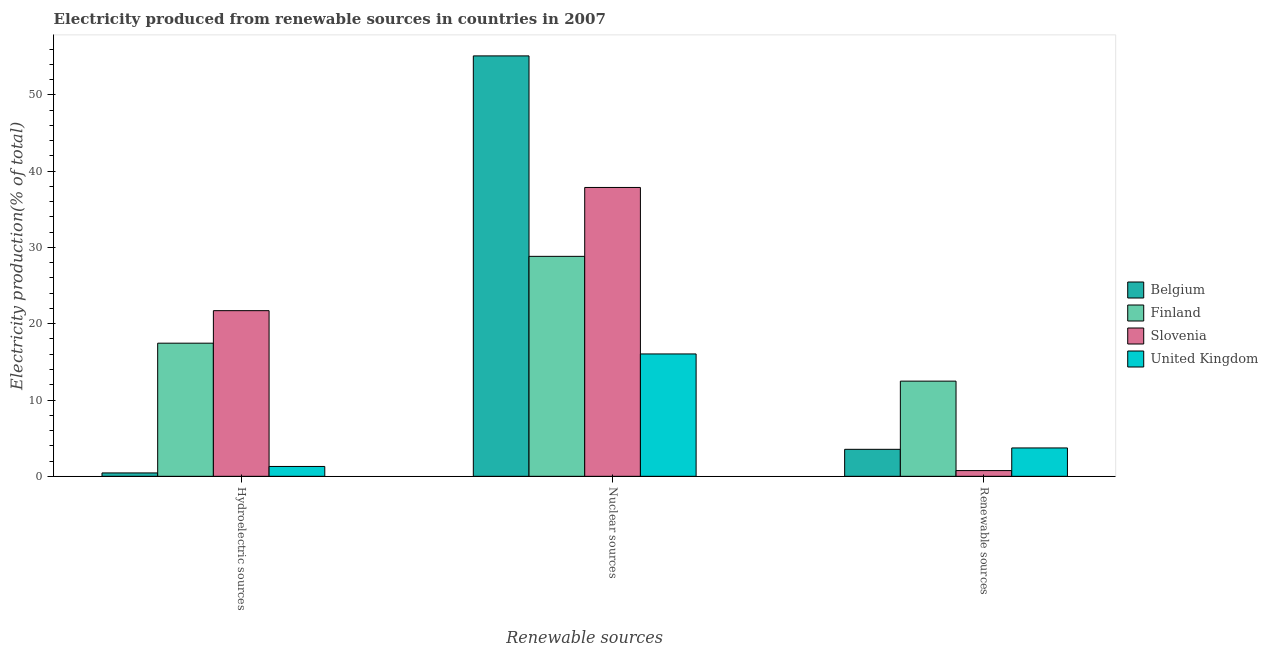How many different coloured bars are there?
Your answer should be compact. 4. How many groups of bars are there?
Your response must be concise. 3. Are the number of bars on each tick of the X-axis equal?
Your answer should be very brief. Yes. How many bars are there on the 2nd tick from the left?
Give a very brief answer. 4. What is the label of the 2nd group of bars from the left?
Your answer should be compact. Nuclear sources. What is the percentage of electricity produced by renewable sources in United Kingdom?
Your response must be concise. 3.72. Across all countries, what is the maximum percentage of electricity produced by nuclear sources?
Provide a succinct answer. 55.1. Across all countries, what is the minimum percentage of electricity produced by nuclear sources?
Offer a terse response. 16.04. In which country was the percentage of electricity produced by hydroelectric sources maximum?
Your answer should be compact. Slovenia. What is the total percentage of electricity produced by hydroelectric sources in the graph?
Offer a terse response. 40.9. What is the difference between the percentage of electricity produced by hydroelectric sources in United Kingdom and that in Finland?
Your answer should be very brief. -16.16. What is the difference between the percentage of electricity produced by renewable sources in Belgium and the percentage of electricity produced by hydroelectric sources in United Kingdom?
Provide a short and direct response. 2.25. What is the average percentage of electricity produced by hydroelectric sources per country?
Your answer should be very brief. 10.22. What is the difference between the percentage of electricity produced by nuclear sources and percentage of electricity produced by renewable sources in Belgium?
Your response must be concise. 51.56. What is the ratio of the percentage of electricity produced by renewable sources in United Kingdom to that in Slovenia?
Offer a terse response. 4.95. Is the percentage of electricity produced by hydroelectric sources in United Kingdom less than that in Slovenia?
Give a very brief answer. Yes. What is the difference between the highest and the second highest percentage of electricity produced by renewable sources?
Ensure brevity in your answer.  8.76. What is the difference between the highest and the lowest percentage of electricity produced by renewable sources?
Provide a short and direct response. 11.72. In how many countries, is the percentage of electricity produced by renewable sources greater than the average percentage of electricity produced by renewable sources taken over all countries?
Offer a very short reply. 1. What does the 2nd bar from the right in Nuclear sources represents?
Keep it short and to the point. Slovenia. Is it the case that in every country, the sum of the percentage of electricity produced by hydroelectric sources and percentage of electricity produced by nuclear sources is greater than the percentage of electricity produced by renewable sources?
Provide a short and direct response. Yes. How many bars are there?
Your answer should be very brief. 12. Are all the bars in the graph horizontal?
Provide a succinct answer. No. How many countries are there in the graph?
Your answer should be very brief. 4. Does the graph contain grids?
Keep it short and to the point. No. How are the legend labels stacked?
Keep it short and to the point. Vertical. What is the title of the graph?
Offer a terse response. Electricity produced from renewable sources in countries in 2007. What is the label or title of the X-axis?
Ensure brevity in your answer.  Renewable sources. What is the label or title of the Y-axis?
Your answer should be very brief. Electricity production(% of total). What is the Electricity production(% of total) of Belgium in Hydroelectric sources?
Your response must be concise. 0.44. What is the Electricity production(% of total) in Finland in Hydroelectric sources?
Your answer should be very brief. 17.45. What is the Electricity production(% of total) of Slovenia in Hydroelectric sources?
Provide a short and direct response. 21.71. What is the Electricity production(% of total) of United Kingdom in Hydroelectric sources?
Your response must be concise. 1.29. What is the Electricity production(% of total) of Belgium in Nuclear sources?
Your answer should be very brief. 55.1. What is the Electricity production(% of total) in Finland in Nuclear sources?
Your response must be concise. 28.83. What is the Electricity production(% of total) in Slovenia in Nuclear sources?
Keep it short and to the point. 37.86. What is the Electricity production(% of total) in United Kingdom in Nuclear sources?
Give a very brief answer. 16.04. What is the Electricity production(% of total) of Belgium in Renewable sources?
Provide a succinct answer. 3.54. What is the Electricity production(% of total) of Finland in Renewable sources?
Keep it short and to the point. 12.47. What is the Electricity production(% of total) of Slovenia in Renewable sources?
Provide a succinct answer. 0.75. What is the Electricity production(% of total) in United Kingdom in Renewable sources?
Your response must be concise. 3.72. Across all Renewable sources, what is the maximum Electricity production(% of total) of Belgium?
Provide a short and direct response. 55.1. Across all Renewable sources, what is the maximum Electricity production(% of total) of Finland?
Your answer should be very brief. 28.83. Across all Renewable sources, what is the maximum Electricity production(% of total) of Slovenia?
Ensure brevity in your answer.  37.86. Across all Renewable sources, what is the maximum Electricity production(% of total) in United Kingdom?
Provide a short and direct response. 16.04. Across all Renewable sources, what is the minimum Electricity production(% of total) in Belgium?
Offer a very short reply. 0.44. Across all Renewable sources, what is the minimum Electricity production(% of total) of Finland?
Ensure brevity in your answer.  12.47. Across all Renewable sources, what is the minimum Electricity production(% of total) of Slovenia?
Offer a terse response. 0.75. Across all Renewable sources, what is the minimum Electricity production(% of total) of United Kingdom?
Ensure brevity in your answer.  1.29. What is the total Electricity production(% of total) in Belgium in the graph?
Your answer should be very brief. 59.08. What is the total Electricity production(% of total) in Finland in the graph?
Provide a succinct answer. 58.75. What is the total Electricity production(% of total) in Slovenia in the graph?
Provide a succinct answer. 60.32. What is the total Electricity production(% of total) of United Kingdom in the graph?
Ensure brevity in your answer.  21.05. What is the difference between the Electricity production(% of total) of Belgium in Hydroelectric sources and that in Nuclear sources?
Your answer should be compact. -54.66. What is the difference between the Electricity production(% of total) in Finland in Hydroelectric sources and that in Nuclear sources?
Provide a short and direct response. -11.38. What is the difference between the Electricity production(% of total) in Slovenia in Hydroelectric sources and that in Nuclear sources?
Ensure brevity in your answer.  -16.15. What is the difference between the Electricity production(% of total) in United Kingdom in Hydroelectric sources and that in Nuclear sources?
Your answer should be compact. -14.75. What is the difference between the Electricity production(% of total) in Belgium in Hydroelectric sources and that in Renewable sources?
Your answer should be very brief. -3.09. What is the difference between the Electricity production(% of total) of Finland in Hydroelectric sources and that in Renewable sources?
Your answer should be compact. 4.97. What is the difference between the Electricity production(% of total) in Slovenia in Hydroelectric sources and that in Renewable sources?
Keep it short and to the point. 20.96. What is the difference between the Electricity production(% of total) of United Kingdom in Hydroelectric sources and that in Renewable sources?
Your answer should be very brief. -2.43. What is the difference between the Electricity production(% of total) of Belgium in Nuclear sources and that in Renewable sources?
Your answer should be compact. 51.56. What is the difference between the Electricity production(% of total) in Finland in Nuclear sources and that in Renewable sources?
Provide a succinct answer. 16.36. What is the difference between the Electricity production(% of total) in Slovenia in Nuclear sources and that in Renewable sources?
Your answer should be compact. 37.11. What is the difference between the Electricity production(% of total) in United Kingdom in Nuclear sources and that in Renewable sources?
Provide a short and direct response. 12.32. What is the difference between the Electricity production(% of total) of Belgium in Hydroelectric sources and the Electricity production(% of total) of Finland in Nuclear sources?
Your answer should be very brief. -28.38. What is the difference between the Electricity production(% of total) of Belgium in Hydroelectric sources and the Electricity production(% of total) of Slovenia in Nuclear sources?
Offer a terse response. -37.41. What is the difference between the Electricity production(% of total) in Belgium in Hydroelectric sources and the Electricity production(% of total) in United Kingdom in Nuclear sources?
Make the answer very short. -15.59. What is the difference between the Electricity production(% of total) of Finland in Hydroelectric sources and the Electricity production(% of total) of Slovenia in Nuclear sources?
Provide a short and direct response. -20.41. What is the difference between the Electricity production(% of total) in Finland in Hydroelectric sources and the Electricity production(% of total) in United Kingdom in Nuclear sources?
Offer a very short reply. 1.41. What is the difference between the Electricity production(% of total) in Slovenia in Hydroelectric sources and the Electricity production(% of total) in United Kingdom in Nuclear sources?
Offer a very short reply. 5.67. What is the difference between the Electricity production(% of total) of Belgium in Hydroelectric sources and the Electricity production(% of total) of Finland in Renewable sources?
Your answer should be compact. -12.03. What is the difference between the Electricity production(% of total) in Belgium in Hydroelectric sources and the Electricity production(% of total) in Slovenia in Renewable sources?
Offer a terse response. -0.31. What is the difference between the Electricity production(% of total) of Belgium in Hydroelectric sources and the Electricity production(% of total) of United Kingdom in Renewable sources?
Provide a succinct answer. -3.27. What is the difference between the Electricity production(% of total) of Finland in Hydroelectric sources and the Electricity production(% of total) of Slovenia in Renewable sources?
Your answer should be compact. 16.7. What is the difference between the Electricity production(% of total) of Finland in Hydroelectric sources and the Electricity production(% of total) of United Kingdom in Renewable sources?
Provide a succinct answer. 13.73. What is the difference between the Electricity production(% of total) of Slovenia in Hydroelectric sources and the Electricity production(% of total) of United Kingdom in Renewable sources?
Provide a short and direct response. 17.99. What is the difference between the Electricity production(% of total) of Belgium in Nuclear sources and the Electricity production(% of total) of Finland in Renewable sources?
Make the answer very short. 42.63. What is the difference between the Electricity production(% of total) in Belgium in Nuclear sources and the Electricity production(% of total) in Slovenia in Renewable sources?
Your answer should be very brief. 54.35. What is the difference between the Electricity production(% of total) in Belgium in Nuclear sources and the Electricity production(% of total) in United Kingdom in Renewable sources?
Provide a short and direct response. 51.38. What is the difference between the Electricity production(% of total) of Finland in Nuclear sources and the Electricity production(% of total) of Slovenia in Renewable sources?
Your answer should be compact. 28.08. What is the difference between the Electricity production(% of total) of Finland in Nuclear sources and the Electricity production(% of total) of United Kingdom in Renewable sources?
Give a very brief answer. 25.11. What is the difference between the Electricity production(% of total) of Slovenia in Nuclear sources and the Electricity production(% of total) of United Kingdom in Renewable sources?
Your response must be concise. 34.14. What is the average Electricity production(% of total) in Belgium per Renewable sources?
Keep it short and to the point. 19.69. What is the average Electricity production(% of total) in Finland per Renewable sources?
Keep it short and to the point. 19.58. What is the average Electricity production(% of total) in Slovenia per Renewable sources?
Your answer should be compact. 20.11. What is the average Electricity production(% of total) in United Kingdom per Renewable sources?
Ensure brevity in your answer.  7.02. What is the difference between the Electricity production(% of total) in Belgium and Electricity production(% of total) in Finland in Hydroelectric sources?
Provide a short and direct response. -17. What is the difference between the Electricity production(% of total) in Belgium and Electricity production(% of total) in Slovenia in Hydroelectric sources?
Make the answer very short. -21.27. What is the difference between the Electricity production(% of total) of Belgium and Electricity production(% of total) of United Kingdom in Hydroelectric sources?
Your answer should be compact. -0.85. What is the difference between the Electricity production(% of total) in Finland and Electricity production(% of total) in Slovenia in Hydroelectric sources?
Keep it short and to the point. -4.26. What is the difference between the Electricity production(% of total) of Finland and Electricity production(% of total) of United Kingdom in Hydroelectric sources?
Provide a succinct answer. 16.16. What is the difference between the Electricity production(% of total) of Slovenia and Electricity production(% of total) of United Kingdom in Hydroelectric sources?
Your answer should be compact. 20.42. What is the difference between the Electricity production(% of total) in Belgium and Electricity production(% of total) in Finland in Nuclear sources?
Keep it short and to the point. 26.27. What is the difference between the Electricity production(% of total) in Belgium and Electricity production(% of total) in Slovenia in Nuclear sources?
Keep it short and to the point. 17.24. What is the difference between the Electricity production(% of total) in Belgium and Electricity production(% of total) in United Kingdom in Nuclear sources?
Offer a very short reply. 39.06. What is the difference between the Electricity production(% of total) of Finland and Electricity production(% of total) of Slovenia in Nuclear sources?
Offer a very short reply. -9.03. What is the difference between the Electricity production(% of total) of Finland and Electricity production(% of total) of United Kingdom in Nuclear sources?
Ensure brevity in your answer.  12.79. What is the difference between the Electricity production(% of total) in Slovenia and Electricity production(% of total) in United Kingdom in Nuclear sources?
Offer a very short reply. 21.82. What is the difference between the Electricity production(% of total) in Belgium and Electricity production(% of total) in Finland in Renewable sources?
Keep it short and to the point. -8.94. What is the difference between the Electricity production(% of total) in Belgium and Electricity production(% of total) in Slovenia in Renewable sources?
Provide a succinct answer. 2.79. What is the difference between the Electricity production(% of total) of Belgium and Electricity production(% of total) of United Kingdom in Renewable sources?
Ensure brevity in your answer.  -0.18. What is the difference between the Electricity production(% of total) of Finland and Electricity production(% of total) of Slovenia in Renewable sources?
Offer a terse response. 11.72. What is the difference between the Electricity production(% of total) in Finland and Electricity production(% of total) in United Kingdom in Renewable sources?
Your answer should be compact. 8.76. What is the difference between the Electricity production(% of total) in Slovenia and Electricity production(% of total) in United Kingdom in Renewable sources?
Give a very brief answer. -2.97. What is the ratio of the Electricity production(% of total) in Belgium in Hydroelectric sources to that in Nuclear sources?
Ensure brevity in your answer.  0.01. What is the ratio of the Electricity production(% of total) in Finland in Hydroelectric sources to that in Nuclear sources?
Your answer should be compact. 0.61. What is the ratio of the Electricity production(% of total) of Slovenia in Hydroelectric sources to that in Nuclear sources?
Your answer should be very brief. 0.57. What is the ratio of the Electricity production(% of total) in United Kingdom in Hydroelectric sources to that in Nuclear sources?
Your answer should be very brief. 0.08. What is the ratio of the Electricity production(% of total) in Belgium in Hydroelectric sources to that in Renewable sources?
Your response must be concise. 0.13. What is the ratio of the Electricity production(% of total) of Finland in Hydroelectric sources to that in Renewable sources?
Offer a terse response. 1.4. What is the ratio of the Electricity production(% of total) in Slovenia in Hydroelectric sources to that in Renewable sources?
Offer a very short reply. 28.9. What is the ratio of the Electricity production(% of total) of United Kingdom in Hydroelectric sources to that in Renewable sources?
Offer a terse response. 0.35. What is the ratio of the Electricity production(% of total) of Belgium in Nuclear sources to that in Renewable sources?
Provide a short and direct response. 15.57. What is the ratio of the Electricity production(% of total) in Finland in Nuclear sources to that in Renewable sources?
Provide a succinct answer. 2.31. What is the ratio of the Electricity production(% of total) in Slovenia in Nuclear sources to that in Renewable sources?
Your answer should be very brief. 50.4. What is the ratio of the Electricity production(% of total) of United Kingdom in Nuclear sources to that in Renewable sources?
Give a very brief answer. 4.31. What is the difference between the highest and the second highest Electricity production(% of total) in Belgium?
Your answer should be very brief. 51.56. What is the difference between the highest and the second highest Electricity production(% of total) in Finland?
Keep it short and to the point. 11.38. What is the difference between the highest and the second highest Electricity production(% of total) of Slovenia?
Your answer should be compact. 16.15. What is the difference between the highest and the second highest Electricity production(% of total) in United Kingdom?
Offer a terse response. 12.32. What is the difference between the highest and the lowest Electricity production(% of total) in Belgium?
Make the answer very short. 54.66. What is the difference between the highest and the lowest Electricity production(% of total) in Finland?
Make the answer very short. 16.36. What is the difference between the highest and the lowest Electricity production(% of total) of Slovenia?
Your answer should be compact. 37.11. What is the difference between the highest and the lowest Electricity production(% of total) of United Kingdom?
Offer a terse response. 14.75. 